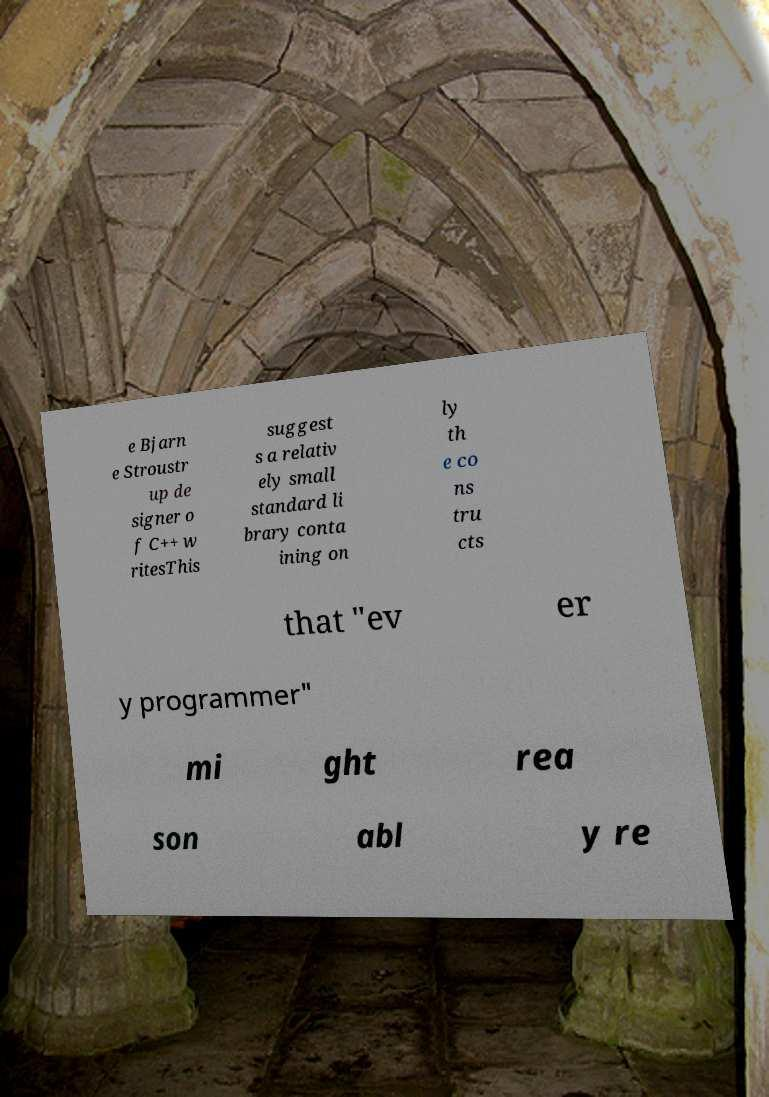Could you extract and type out the text from this image? e Bjarn e Stroustr up de signer o f C++ w ritesThis suggest s a relativ ely small standard li brary conta ining on ly th e co ns tru cts that "ev er y programmer" mi ght rea son abl y re 